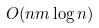Convert formula to latex. <formula><loc_0><loc_0><loc_500><loc_500>O ( n m \log n )</formula> 